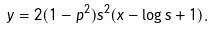<formula> <loc_0><loc_0><loc_500><loc_500>y = 2 ( 1 - p ^ { 2 } ) s ^ { 2 } ( x - \log s + 1 ) .</formula> 